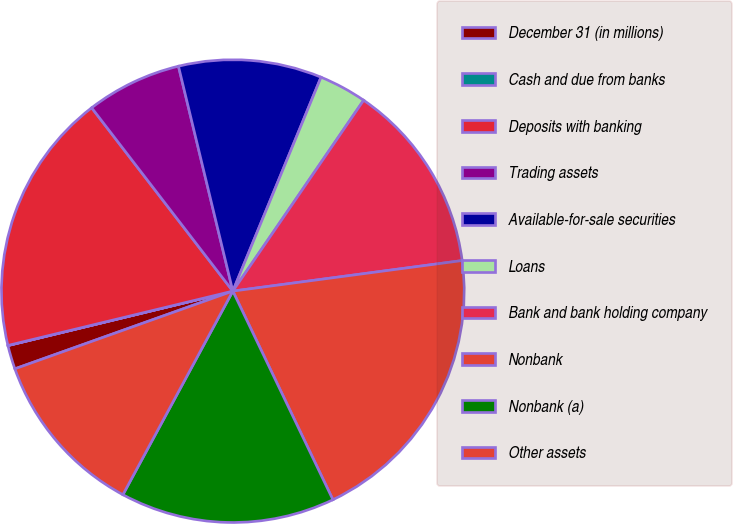<chart> <loc_0><loc_0><loc_500><loc_500><pie_chart><fcel>December 31 (in millions)<fcel>Cash and due from banks<fcel>Deposits with banking<fcel>Trading assets<fcel>Available-for-sale securities<fcel>Loans<fcel>Bank and bank holding company<fcel>Nonbank<fcel>Nonbank (a)<fcel>Other assets<nl><fcel>1.67%<fcel>0.01%<fcel>18.33%<fcel>6.67%<fcel>10.0%<fcel>3.34%<fcel>13.33%<fcel>19.99%<fcel>15.0%<fcel>11.67%<nl></chart> 